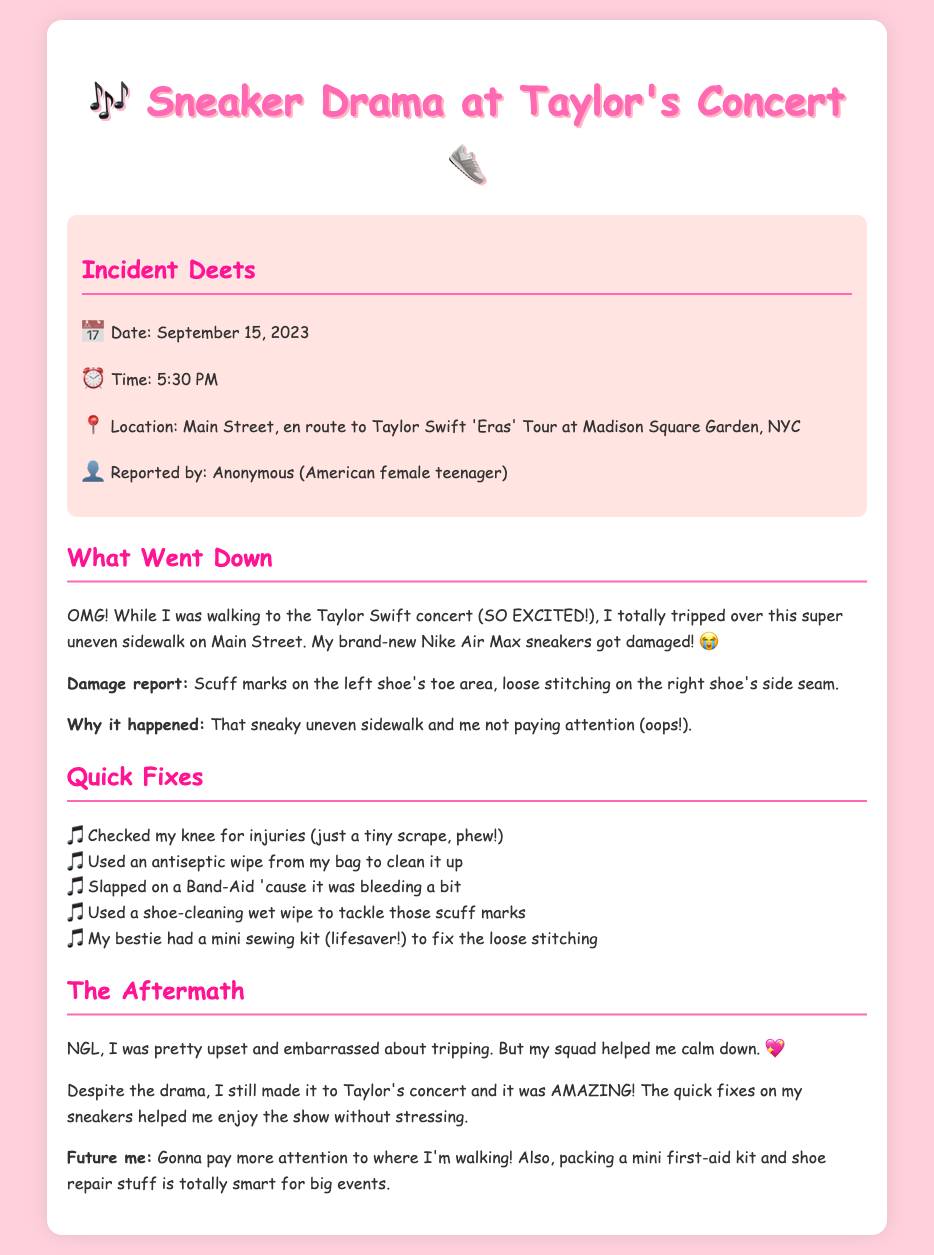What date did the incident occur? The incident date is mentioned in the document under "Incident Deets."
Answer: September 15, 2023 What was the time of the incident? The time is specified in the "Incident Deets" section of the document.
Answer: 5:30 PM Where did the incident happen? The location is described in the document, highlighting the route to the concert.
Answer: Main Street, en route to Taylor Swift 'Eras' Tour at Madison Square Garden, NYC What type of sneakers were damaged? The document specifies the brand and model of the sneakers in the incident description.
Answer: Nike Air Max What was the specific damage to the sneakers? The damage report in the document lists the specific issues with the shoes.
Answer: Scuff marks on the left shoe's toe area, loose stitching on the right shoe's side seam What did the report say about the author's knee? The "Quick Fixes" section notes the condition of the author's knee after the trip.
Answer: Just a tiny scrape What helped fix the loose stitching? The document states that a mini sewing kit was used to repair the shoes.
Answer: A mini sewing kit How did the author feel after tripping? The "Aftermath" section describes the author's feelings post-incident.
Answer: Upset and embarrassed What was a suggestion for future events? The last part of the document includes a suggestion for future preparedness.
Answer: Packing a mini first-aid kit and shoe repair stuff 